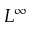Convert formula to latex. <formula><loc_0><loc_0><loc_500><loc_500>L ^ { \infty }</formula> 